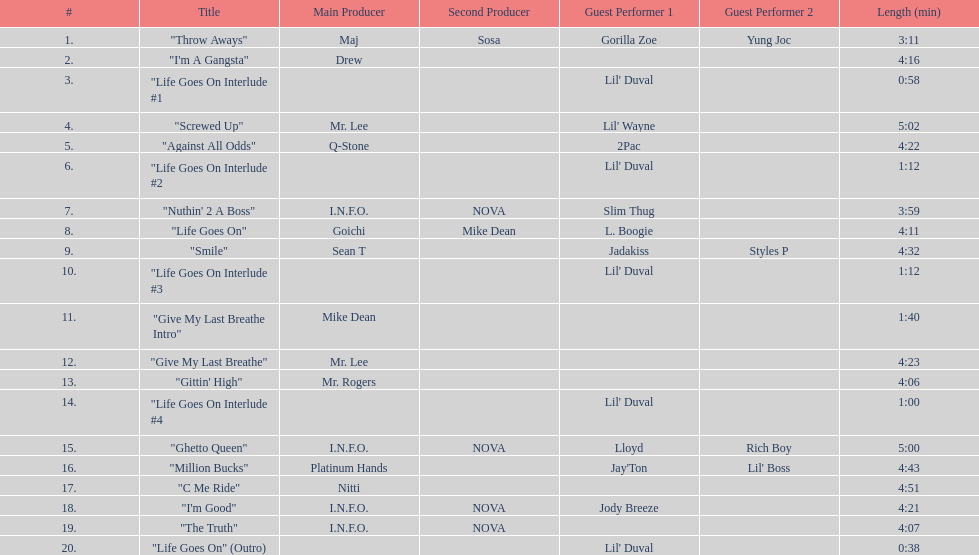What is the last track produced by mr. lee? "Give My Last Breathe". 